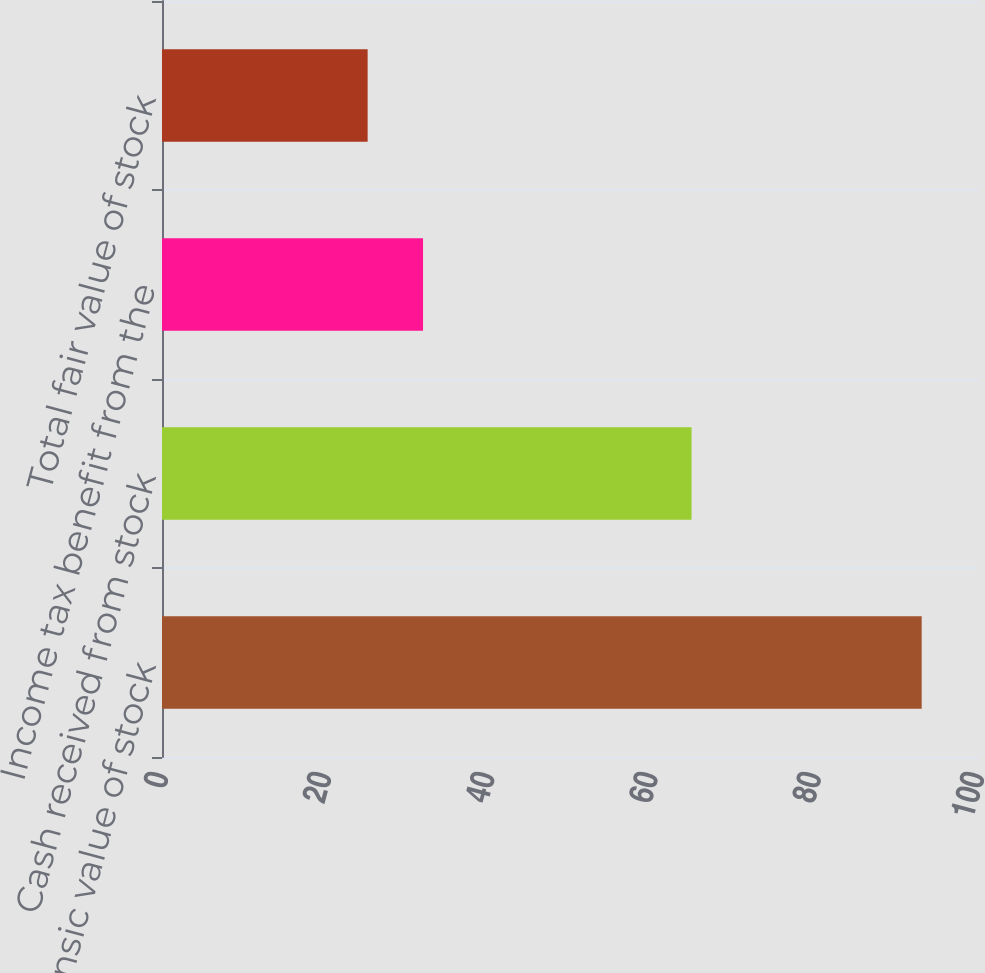Convert chart. <chart><loc_0><loc_0><loc_500><loc_500><bar_chart><fcel>Total intrinsic value of stock<fcel>Cash received from stock<fcel>Income tax benefit from the<fcel>Total fair value of stock<nl><fcel>93.1<fcel>64.9<fcel>31.99<fcel>25.2<nl></chart> 